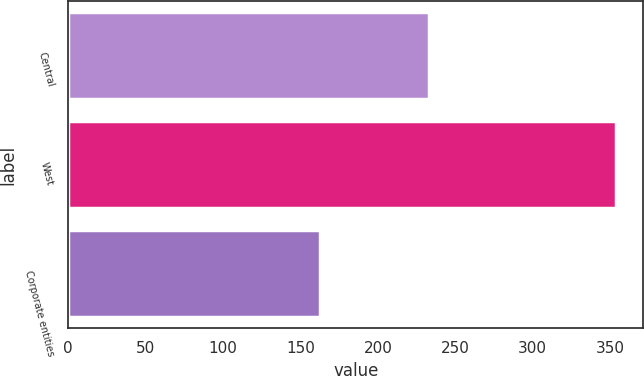Convert chart to OTSL. <chart><loc_0><loc_0><loc_500><loc_500><bar_chart><fcel>Central<fcel>West<fcel>Corporate entities<nl><fcel>233.1<fcel>353.8<fcel>162.7<nl></chart> 